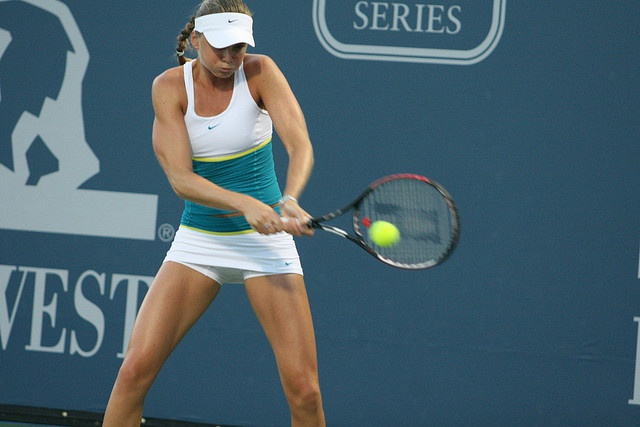Describe the objects in this image and their specific colors. I can see people in gray, lightgray, tan, and teal tones, tennis racket in gray, blue, black, and darkgray tones, and sports ball in gray, yellow, lightgreen, and green tones in this image. 